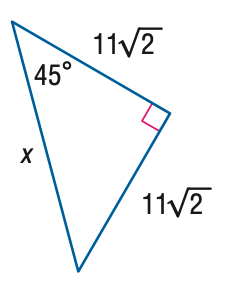Answer the mathemtical geometry problem and directly provide the correct option letter.
Question: Find x.
Choices: A: 11 B: 22 C: 22 \sqrt { 2 } D: 44 B 